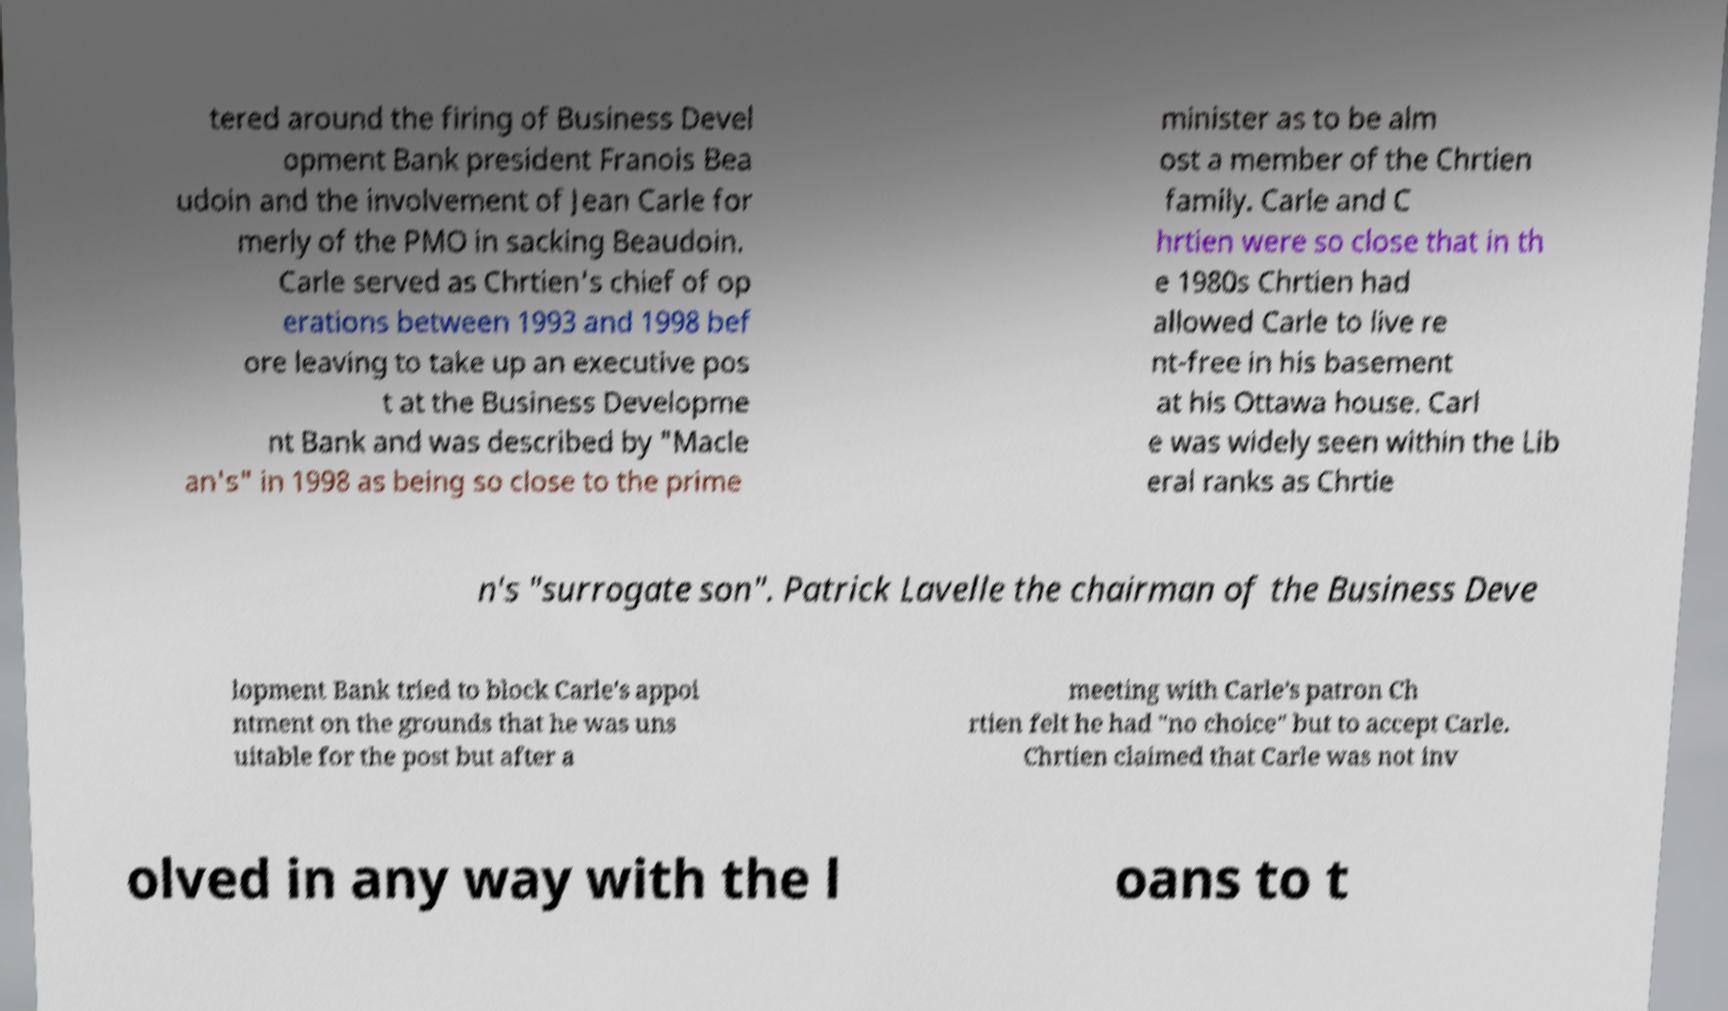What messages or text are displayed in this image? I need them in a readable, typed format. tered around the firing of Business Devel opment Bank president Franois Bea udoin and the involvement of Jean Carle for merly of the PMO in sacking Beaudoin. Carle served as Chrtien's chief of op erations between 1993 and 1998 bef ore leaving to take up an executive pos t at the Business Developme nt Bank and was described by "Macle an's" in 1998 as being so close to the prime minister as to be alm ost a member of the Chrtien family. Carle and C hrtien were so close that in th e 1980s Chrtien had allowed Carle to live re nt-free in his basement at his Ottawa house. Carl e was widely seen within the Lib eral ranks as Chrtie n's "surrogate son". Patrick Lavelle the chairman of the Business Deve lopment Bank tried to block Carle's appoi ntment on the grounds that he was uns uitable for the post but after a meeting with Carle's patron Ch rtien felt he had "no choice" but to accept Carle. Chrtien claimed that Carle was not inv olved in any way with the l oans to t 